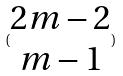<formula> <loc_0><loc_0><loc_500><loc_500>( \begin{matrix} 2 m - 2 \\ m - 1 \end{matrix} )</formula> 